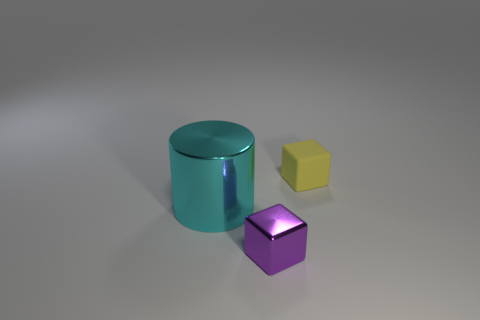Add 3 small metal things. How many objects exist? 6 Subtract 0 blue cylinders. How many objects are left? 3 Subtract all cylinders. How many objects are left? 2 Subtract all big shiny cylinders. Subtract all tiny purple metallic objects. How many objects are left? 1 Add 1 tiny purple objects. How many tiny purple objects are left? 2 Add 1 purple blocks. How many purple blocks exist? 2 